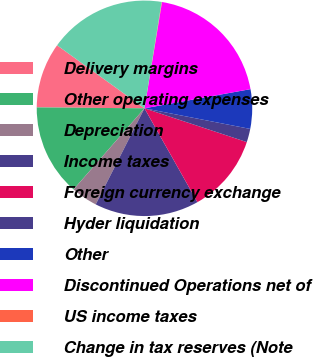<chart> <loc_0><loc_0><loc_500><loc_500><pie_chart><fcel>Delivery margins<fcel>Other operating expenses<fcel>Depreciation<fcel>Income taxes<fcel>Foreign currency exchange<fcel>Hyder liquidation<fcel>Other<fcel>Discontinued Operations net of<fcel>US income taxes<fcel>Change in tax reserves (Note<nl><fcel>9.81%<fcel>13.7%<fcel>3.96%<fcel>15.65%<fcel>11.75%<fcel>2.01%<fcel>5.91%<fcel>19.55%<fcel>0.06%<fcel>17.6%<nl></chart> 